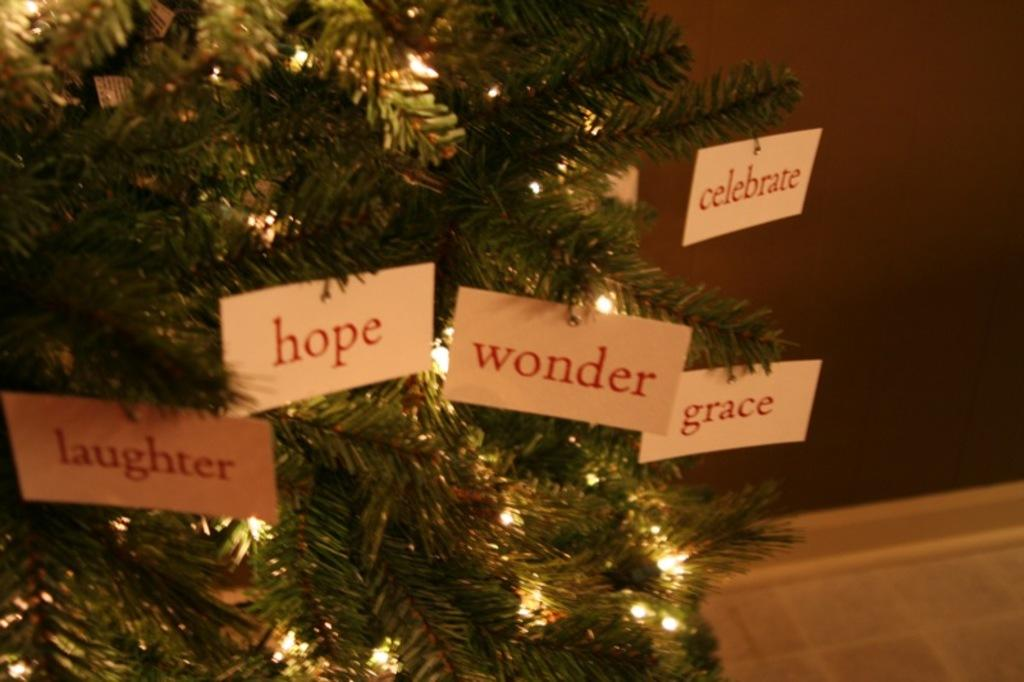What type of plant can be seen in the image? There is a tree in the image. What else is visible in the image besides the tree? There are lights, cards, a wall, and a floor visible in the image. What is written on the cards in the image? Something is written on the cards in the image. How many chairs are placed around the tree in the image? There are no chairs present in the image. What is the stomach condition of the tree in the image? Trees do not have stomachs, so this question cannot be answered. 